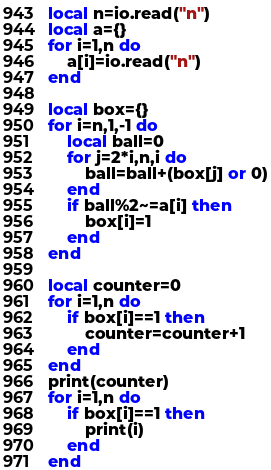<code> <loc_0><loc_0><loc_500><loc_500><_Lua_>local n=io.read("n")
local a={}
for i=1,n do
    a[i]=io.read("n")
end

local box={}
for i=n,1,-1 do
    local ball=0
    for j=2*i,n,i do
        ball=ball+(box[j] or 0)
    end
    if ball%2~=a[i] then
        box[i]=1
    end
end

local counter=0
for i=1,n do
    if box[i]==1 then
        counter=counter+1
    end
end
print(counter)
for i=1,n do
    if box[i]==1 then
        print(i)
    end
end</code> 